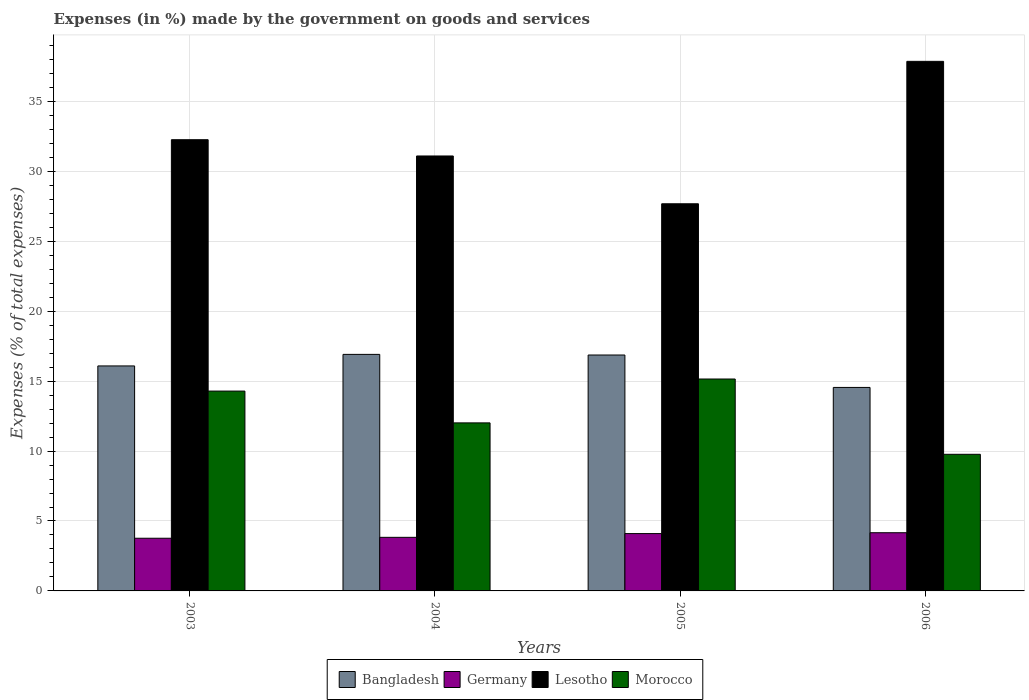How many bars are there on the 3rd tick from the right?
Your answer should be compact. 4. What is the percentage of expenses made by the government on goods and services in Bangladesh in 2003?
Your answer should be compact. 16.09. Across all years, what is the maximum percentage of expenses made by the government on goods and services in Lesotho?
Your answer should be very brief. 37.86. Across all years, what is the minimum percentage of expenses made by the government on goods and services in Morocco?
Provide a succinct answer. 9.77. What is the total percentage of expenses made by the government on goods and services in Germany in the graph?
Offer a very short reply. 15.86. What is the difference between the percentage of expenses made by the government on goods and services in Morocco in 2004 and that in 2005?
Ensure brevity in your answer.  -3.14. What is the difference between the percentage of expenses made by the government on goods and services in Morocco in 2003 and the percentage of expenses made by the government on goods and services in Lesotho in 2006?
Offer a terse response. -23.58. What is the average percentage of expenses made by the government on goods and services in Germany per year?
Make the answer very short. 3.96. In the year 2005, what is the difference between the percentage of expenses made by the government on goods and services in Morocco and percentage of expenses made by the government on goods and services in Lesotho?
Your response must be concise. -12.53. What is the ratio of the percentage of expenses made by the government on goods and services in Bangladesh in 2003 to that in 2005?
Provide a short and direct response. 0.95. Is the difference between the percentage of expenses made by the government on goods and services in Morocco in 2003 and 2006 greater than the difference between the percentage of expenses made by the government on goods and services in Lesotho in 2003 and 2006?
Provide a short and direct response. Yes. What is the difference between the highest and the second highest percentage of expenses made by the government on goods and services in Morocco?
Your answer should be very brief. 0.86. What is the difference between the highest and the lowest percentage of expenses made by the government on goods and services in Bangladesh?
Provide a short and direct response. 2.36. In how many years, is the percentage of expenses made by the government on goods and services in Lesotho greater than the average percentage of expenses made by the government on goods and services in Lesotho taken over all years?
Offer a terse response. 2. Is it the case that in every year, the sum of the percentage of expenses made by the government on goods and services in Morocco and percentage of expenses made by the government on goods and services in Lesotho is greater than the sum of percentage of expenses made by the government on goods and services in Germany and percentage of expenses made by the government on goods and services in Bangladesh?
Your answer should be very brief. No. What does the 4th bar from the left in 2004 represents?
Give a very brief answer. Morocco. What does the 1st bar from the right in 2004 represents?
Provide a succinct answer. Morocco. Is it the case that in every year, the sum of the percentage of expenses made by the government on goods and services in Bangladesh and percentage of expenses made by the government on goods and services in Morocco is greater than the percentage of expenses made by the government on goods and services in Lesotho?
Offer a very short reply. No. Are all the bars in the graph horizontal?
Provide a succinct answer. No. What is the difference between two consecutive major ticks on the Y-axis?
Provide a short and direct response. 5. Does the graph contain any zero values?
Make the answer very short. No. Does the graph contain grids?
Provide a succinct answer. Yes. Where does the legend appear in the graph?
Offer a very short reply. Bottom center. How many legend labels are there?
Provide a succinct answer. 4. What is the title of the graph?
Offer a very short reply. Expenses (in %) made by the government on goods and services. What is the label or title of the Y-axis?
Offer a terse response. Expenses (% of total expenses). What is the Expenses (% of total expenses) in Bangladesh in 2003?
Make the answer very short. 16.09. What is the Expenses (% of total expenses) in Germany in 2003?
Offer a terse response. 3.77. What is the Expenses (% of total expenses) of Lesotho in 2003?
Your answer should be compact. 32.26. What is the Expenses (% of total expenses) of Morocco in 2003?
Keep it short and to the point. 14.29. What is the Expenses (% of total expenses) of Bangladesh in 2004?
Give a very brief answer. 16.91. What is the Expenses (% of total expenses) of Germany in 2004?
Provide a short and direct response. 3.83. What is the Expenses (% of total expenses) of Lesotho in 2004?
Make the answer very short. 31.1. What is the Expenses (% of total expenses) of Morocco in 2004?
Provide a succinct answer. 12.01. What is the Expenses (% of total expenses) of Bangladesh in 2005?
Your response must be concise. 16.87. What is the Expenses (% of total expenses) of Germany in 2005?
Your answer should be compact. 4.1. What is the Expenses (% of total expenses) of Lesotho in 2005?
Your answer should be compact. 27.68. What is the Expenses (% of total expenses) of Morocco in 2005?
Provide a short and direct response. 15.15. What is the Expenses (% of total expenses) in Bangladesh in 2006?
Offer a very short reply. 14.55. What is the Expenses (% of total expenses) of Germany in 2006?
Give a very brief answer. 4.16. What is the Expenses (% of total expenses) in Lesotho in 2006?
Offer a very short reply. 37.86. What is the Expenses (% of total expenses) of Morocco in 2006?
Offer a terse response. 9.77. Across all years, what is the maximum Expenses (% of total expenses) in Bangladesh?
Offer a very short reply. 16.91. Across all years, what is the maximum Expenses (% of total expenses) of Germany?
Make the answer very short. 4.16. Across all years, what is the maximum Expenses (% of total expenses) of Lesotho?
Offer a very short reply. 37.86. Across all years, what is the maximum Expenses (% of total expenses) of Morocco?
Your response must be concise. 15.15. Across all years, what is the minimum Expenses (% of total expenses) of Bangladesh?
Provide a short and direct response. 14.55. Across all years, what is the minimum Expenses (% of total expenses) in Germany?
Offer a very short reply. 3.77. Across all years, what is the minimum Expenses (% of total expenses) in Lesotho?
Make the answer very short. 27.68. Across all years, what is the minimum Expenses (% of total expenses) in Morocco?
Ensure brevity in your answer.  9.77. What is the total Expenses (% of total expenses) of Bangladesh in the graph?
Provide a short and direct response. 64.42. What is the total Expenses (% of total expenses) of Germany in the graph?
Your answer should be compact. 15.86. What is the total Expenses (% of total expenses) in Lesotho in the graph?
Ensure brevity in your answer.  128.9. What is the total Expenses (% of total expenses) of Morocco in the graph?
Your answer should be very brief. 51.22. What is the difference between the Expenses (% of total expenses) of Bangladesh in 2003 and that in 2004?
Provide a succinct answer. -0.83. What is the difference between the Expenses (% of total expenses) in Germany in 2003 and that in 2004?
Provide a succinct answer. -0.06. What is the difference between the Expenses (% of total expenses) of Lesotho in 2003 and that in 2004?
Offer a very short reply. 1.16. What is the difference between the Expenses (% of total expenses) in Morocco in 2003 and that in 2004?
Give a very brief answer. 2.27. What is the difference between the Expenses (% of total expenses) in Bangladesh in 2003 and that in 2005?
Ensure brevity in your answer.  -0.78. What is the difference between the Expenses (% of total expenses) in Germany in 2003 and that in 2005?
Make the answer very short. -0.33. What is the difference between the Expenses (% of total expenses) of Lesotho in 2003 and that in 2005?
Ensure brevity in your answer.  4.58. What is the difference between the Expenses (% of total expenses) of Morocco in 2003 and that in 2005?
Your answer should be compact. -0.86. What is the difference between the Expenses (% of total expenses) of Bangladesh in 2003 and that in 2006?
Offer a very short reply. 1.54. What is the difference between the Expenses (% of total expenses) of Germany in 2003 and that in 2006?
Your answer should be compact. -0.39. What is the difference between the Expenses (% of total expenses) in Lesotho in 2003 and that in 2006?
Offer a terse response. -5.6. What is the difference between the Expenses (% of total expenses) of Morocco in 2003 and that in 2006?
Your answer should be very brief. 4.52. What is the difference between the Expenses (% of total expenses) of Bangladesh in 2004 and that in 2005?
Make the answer very short. 0.04. What is the difference between the Expenses (% of total expenses) of Germany in 2004 and that in 2005?
Give a very brief answer. -0.27. What is the difference between the Expenses (% of total expenses) of Lesotho in 2004 and that in 2005?
Ensure brevity in your answer.  3.42. What is the difference between the Expenses (% of total expenses) in Morocco in 2004 and that in 2005?
Offer a very short reply. -3.14. What is the difference between the Expenses (% of total expenses) of Bangladesh in 2004 and that in 2006?
Ensure brevity in your answer.  2.36. What is the difference between the Expenses (% of total expenses) in Germany in 2004 and that in 2006?
Keep it short and to the point. -0.33. What is the difference between the Expenses (% of total expenses) in Lesotho in 2004 and that in 2006?
Your response must be concise. -6.77. What is the difference between the Expenses (% of total expenses) of Morocco in 2004 and that in 2006?
Ensure brevity in your answer.  2.25. What is the difference between the Expenses (% of total expenses) in Bangladesh in 2005 and that in 2006?
Offer a very short reply. 2.32. What is the difference between the Expenses (% of total expenses) of Germany in 2005 and that in 2006?
Make the answer very short. -0.06. What is the difference between the Expenses (% of total expenses) in Lesotho in 2005 and that in 2006?
Make the answer very short. -10.18. What is the difference between the Expenses (% of total expenses) of Morocco in 2005 and that in 2006?
Provide a short and direct response. 5.38. What is the difference between the Expenses (% of total expenses) in Bangladesh in 2003 and the Expenses (% of total expenses) in Germany in 2004?
Give a very brief answer. 12.26. What is the difference between the Expenses (% of total expenses) in Bangladesh in 2003 and the Expenses (% of total expenses) in Lesotho in 2004?
Ensure brevity in your answer.  -15.01. What is the difference between the Expenses (% of total expenses) in Bangladesh in 2003 and the Expenses (% of total expenses) in Morocco in 2004?
Your answer should be compact. 4.07. What is the difference between the Expenses (% of total expenses) in Germany in 2003 and the Expenses (% of total expenses) in Lesotho in 2004?
Make the answer very short. -27.33. What is the difference between the Expenses (% of total expenses) in Germany in 2003 and the Expenses (% of total expenses) in Morocco in 2004?
Keep it short and to the point. -8.25. What is the difference between the Expenses (% of total expenses) in Lesotho in 2003 and the Expenses (% of total expenses) in Morocco in 2004?
Your answer should be compact. 20.25. What is the difference between the Expenses (% of total expenses) in Bangladesh in 2003 and the Expenses (% of total expenses) in Germany in 2005?
Make the answer very short. 11.99. What is the difference between the Expenses (% of total expenses) of Bangladesh in 2003 and the Expenses (% of total expenses) of Lesotho in 2005?
Offer a terse response. -11.59. What is the difference between the Expenses (% of total expenses) in Bangladesh in 2003 and the Expenses (% of total expenses) in Morocco in 2005?
Offer a terse response. 0.94. What is the difference between the Expenses (% of total expenses) in Germany in 2003 and the Expenses (% of total expenses) in Lesotho in 2005?
Your response must be concise. -23.91. What is the difference between the Expenses (% of total expenses) of Germany in 2003 and the Expenses (% of total expenses) of Morocco in 2005?
Ensure brevity in your answer.  -11.38. What is the difference between the Expenses (% of total expenses) of Lesotho in 2003 and the Expenses (% of total expenses) of Morocco in 2005?
Your answer should be compact. 17.11. What is the difference between the Expenses (% of total expenses) of Bangladesh in 2003 and the Expenses (% of total expenses) of Germany in 2006?
Keep it short and to the point. 11.93. What is the difference between the Expenses (% of total expenses) in Bangladesh in 2003 and the Expenses (% of total expenses) in Lesotho in 2006?
Make the answer very short. -21.78. What is the difference between the Expenses (% of total expenses) of Bangladesh in 2003 and the Expenses (% of total expenses) of Morocco in 2006?
Offer a terse response. 6.32. What is the difference between the Expenses (% of total expenses) in Germany in 2003 and the Expenses (% of total expenses) in Lesotho in 2006?
Give a very brief answer. -34.1. What is the difference between the Expenses (% of total expenses) of Germany in 2003 and the Expenses (% of total expenses) of Morocco in 2006?
Your answer should be compact. -6. What is the difference between the Expenses (% of total expenses) of Lesotho in 2003 and the Expenses (% of total expenses) of Morocco in 2006?
Ensure brevity in your answer.  22.49. What is the difference between the Expenses (% of total expenses) of Bangladesh in 2004 and the Expenses (% of total expenses) of Germany in 2005?
Offer a terse response. 12.81. What is the difference between the Expenses (% of total expenses) in Bangladesh in 2004 and the Expenses (% of total expenses) in Lesotho in 2005?
Give a very brief answer. -10.77. What is the difference between the Expenses (% of total expenses) in Bangladesh in 2004 and the Expenses (% of total expenses) in Morocco in 2005?
Provide a succinct answer. 1.76. What is the difference between the Expenses (% of total expenses) in Germany in 2004 and the Expenses (% of total expenses) in Lesotho in 2005?
Your response must be concise. -23.85. What is the difference between the Expenses (% of total expenses) of Germany in 2004 and the Expenses (% of total expenses) of Morocco in 2005?
Ensure brevity in your answer.  -11.32. What is the difference between the Expenses (% of total expenses) in Lesotho in 2004 and the Expenses (% of total expenses) in Morocco in 2005?
Give a very brief answer. 15.95. What is the difference between the Expenses (% of total expenses) in Bangladesh in 2004 and the Expenses (% of total expenses) in Germany in 2006?
Offer a terse response. 12.75. What is the difference between the Expenses (% of total expenses) of Bangladesh in 2004 and the Expenses (% of total expenses) of Lesotho in 2006?
Offer a terse response. -20.95. What is the difference between the Expenses (% of total expenses) in Bangladesh in 2004 and the Expenses (% of total expenses) in Morocco in 2006?
Offer a terse response. 7.14. What is the difference between the Expenses (% of total expenses) of Germany in 2004 and the Expenses (% of total expenses) of Lesotho in 2006?
Provide a succinct answer. -34.03. What is the difference between the Expenses (% of total expenses) in Germany in 2004 and the Expenses (% of total expenses) in Morocco in 2006?
Offer a terse response. -5.94. What is the difference between the Expenses (% of total expenses) of Lesotho in 2004 and the Expenses (% of total expenses) of Morocco in 2006?
Offer a terse response. 21.33. What is the difference between the Expenses (% of total expenses) in Bangladesh in 2005 and the Expenses (% of total expenses) in Germany in 2006?
Make the answer very short. 12.71. What is the difference between the Expenses (% of total expenses) in Bangladesh in 2005 and the Expenses (% of total expenses) in Lesotho in 2006?
Make the answer very short. -21. What is the difference between the Expenses (% of total expenses) of Bangladesh in 2005 and the Expenses (% of total expenses) of Morocco in 2006?
Make the answer very short. 7.1. What is the difference between the Expenses (% of total expenses) of Germany in 2005 and the Expenses (% of total expenses) of Lesotho in 2006?
Your answer should be very brief. -33.76. What is the difference between the Expenses (% of total expenses) in Germany in 2005 and the Expenses (% of total expenses) in Morocco in 2006?
Provide a short and direct response. -5.67. What is the difference between the Expenses (% of total expenses) of Lesotho in 2005 and the Expenses (% of total expenses) of Morocco in 2006?
Provide a succinct answer. 17.91. What is the average Expenses (% of total expenses) of Bangladesh per year?
Ensure brevity in your answer.  16.1. What is the average Expenses (% of total expenses) in Germany per year?
Your answer should be very brief. 3.96. What is the average Expenses (% of total expenses) in Lesotho per year?
Your answer should be compact. 32.23. What is the average Expenses (% of total expenses) of Morocco per year?
Your answer should be compact. 12.81. In the year 2003, what is the difference between the Expenses (% of total expenses) of Bangladesh and Expenses (% of total expenses) of Germany?
Give a very brief answer. 12.32. In the year 2003, what is the difference between the Expenses (% of total expenses) of Bangladesh and Expenses (% of total expenses) of Lesotho?
Your response must be concise. -16.17. In the year 2003, what is the difference between the Expenses (% of total expenses) in Bangladesh and Expenses (% of total expenses) in Morocco?
Your answer should be compact. 1.8. In the year 2003, what is the difference between the Expenses (% of total expenses) of Germany and Expenses (% of total expenses) of Lesotho?
Your response must be concise. -28.49. In the year 2003, what is the difference between the Expenses (% of total expenses) of Germany and Expenses (% of total expenses) of Morocco?
Provide a succinct answer. -10.52. In the year 2003, what is the difference between the Expenses (% of total expenses) of Lesotho and Expenses (% of total expenses) of Morocco?
Keep it short and to the point. 17.97. In the year 2004, what is the difference between the Expenses (% of total expenses) of Bangladesh and Expenses (% of total expenses) of Germany?
Your answer should be compact. 13.08. In the year 2004, what is the difference between the Expenses (% of total expenses) in Bangladesh and Expenses (% of total expenses) in Lesotho?
Your answer should be compact. -14.19. In the year 2004, what is the difference between the Expenses (% of total expenses) in Bangladesh and Expenses (% of total expenses) in Morocco?
Your response must be concise. 4.9. In the year 2004, what is the difference between the Expenses (% of total expenses) in Germany and Expenses (% of total expenses) in Lesotho?
Offer a very short reply. -27.27. In the year 2004, what is the difference between the Expenses (% of total expenses) in Germany and Expenses (% of total expenses) in Morocco?
Keep it short and to the point. -8.18. In the year 2004, what is the difference between the Expenses (% of total expenses) of Lesotho and Expenses (% of total expenses) of Morocco?
Offer a very short reply. 19.08. In the year 2005, what is the difference between the Expenses (% of total expenses) in Bangladesh and Expenses (% of total expenses) in Germany?
Offer a terse response. 12.77. In the year 2005, what is the difference between the Expenses (% of total expenses) in Bangladesh and Expenses (% of total expenses) in Lesotho?
Offer a terse response. -10.81. In the year 2005, what is the difference between the Expenses (% of total expenses) in Bangladesh and Expenses (% of total expenses) in Morocco?
Keep it short and to the point. 1.72. In the year 2005, what is the difference between the Expenses (% of total expenses) in Germany and Expenses (% of total expenses) in Lesotho?
Make the answer very short. -23.58. In the year 2005, what is the difference between the Expenses (% of total expenses) in Germany and Expenses (% of total expenses) in Morocco?
Offer a very short reply. -11.05. In the year 2005, what is the difference between the Expenses (% of total expenses) in Lesotho and Expenses (% of total expenses) in Morocco?
Your response must be concise. 12.53. In the year 2006, what is the difference between the Expenses (% of total expenses) in Bangladesh and Expenses (% of total expenses) in Germany?
Your answer should be very brief. 10.39. In the year 2006, what is the difference between the Expenses (% of total expenses) of Bangladesh and Expenses (% of total expenses) of Lesotho?
Provide a short and direct response. -23.31. In the year 2006, what is the difference between the Expenses (% of total expenses) of Bangladesh and Expenses (% of total expenses) of Morocco?
Offer a terse response. 4.78. In the year 2006, what is the difference between the Expenses (% of total expenses) of Germany and Expenses (% of total expenses) of Lesotho?
Your response must be concise. -33.7. In the year 2006, what is the difference between the Expenses (% of total expenses) in Germany and Expenses (% of total expenses) in Morocco?
Give a very brief answer. -5.61. In the year 2006, what is the difference between the Expenses (% of total expenses) in Lesotho and Expenses (% of total expenses) in Morocco?
Provide a short and direct response. 28.09. What is the ratio of the Expenses (% of total expenses) of Bangladesh in 2003 to that in 2004?
Offer a terse response. 0.95. What is the ratio of the Expenses (% of total expenses) in Germany in 2003 to that in 2004?
Offer a terse response. 0.98. What is the ratio of the Expenses (% of total expenses) in Lesotho in 2003 to that in 2004?
Offer a very short reply. 1.04. What is the ratio of the Expenses (% of total expenses) in Morocco in 2003 to that in 2004?
Provide a short and direct response. 1.19. What is the ratio of the Expenses (% of total expenses) of Bangladesh in 2003 to that in 2005?
Make the answer very short. 0.95. What is the ratio of the Expenses (% of total expenses) in Germany in 2003 to that in 2005?
Your answer should be compact. 0.92. What is the ratio of the Expenses (% of total expenses) in Lesotho in 2003 to that in 2005?
Make the answer very short. 1.17. What is the ratio of the Expenses (% of total expenses) of Morocco in 2003 to that in 2005?
Offer a terse response. 0.94. What is the ratio of the Expenses (% of total expenses) of Bangladesh in 2003 to that in 2006?
Keep it short and to the point. 1.11. What is the ratio of the Expenses (% of total expenses) of Germany in 2003 to that in 2006?
Your response must be concise. 0.91. What is the ratio of the Expenses (% of total expenses) in Lesotho in 2003 to that in 2006?
Provide a short and direct response. 0.85. What is the ratio of the Expenses (% of total expenses) in Morocco in 2003 to that in 2006?
Provide a succinct answer. 1.46. What is the ratio of the Expenses (% of total expenses) of Bangladesh in 2004 to that in 2005?
Offer a terse response. 1. What is the ratio of the Expenses (% of total expenses) of Germany in 2004 to that in 2005?
Offer a very short reply. 0.93. What is the ratio of the Expenses (% of total expenses) of Lesotho in 2004 to that in 2005?
Your response must be concise. 1.12. What is the ratio of the Expenses (% of total expenses) in Morocco in 2004 to that in 2005?
Provide a short and direct response. 0.79. What is the ratio of the Expenses (% of total expenses) in Bangladesh in 2004 to that in 2006?
Give a very brief answer. 1.16. What is the ratio of the Expenses (% of total expenses) of Germany in 2004 to that in 2006?
Provide a succinct answer. 0.92. What is the ratio of the Expenses (% of total expenses) in Lesotho in 2004 to that in 2006?
Your answer should be very brief. 0.82. What is the ratio of the Expenses (% of total expenses) of Morocco in 2004 to that in 2006?
Keep it short and to the point. 1.23. What is the ratio of the Expenses (% of total expenses) in Bangladesh in 2005 to that in 2006?
Your answer should be compact. 1.16. What is the ratio of the Expenses (% of total expenses) in Germany in 2005 to that in 2006?
Make the answer very short. 0.99. What is the ratio of the Expenses (% of total expenses) of Lesotho in 2005 to that in 2006?
Provide a short and direct response. 0.73. What is the ratio of the Expenses (% of total expenses) in Morocco in 2005 to that in 2006?
Make the answer very short. 1.55. What is the difference between the highest and the second highest Expenses (% of total expenses) of Bangladesh?
Make the answer very short. 0.04. What is the difference between the highest and the second highest Expenses (% of total expenses) in Germany?
Make the answer very short. 0.06. What is the difference between the highest and the second highest Expenses (% of total expenses) in Lesotho?
Offer a terse response. 5.6. What is the difference between the highest and the second highest Expenses (% of total expenses) in Morocco?
Keep it short and to the point. 0.86. What is the difference between the highest and the lowest Expenses (% of total expenses) of Bangladesh?
Your answer should be compact. 2.36. What is the difference between the highest and the lowest Expenses (% of total expenses) of Germany?
Give a very brief answer. 0.39. What is the difference between the highest and the lowest Expenses (% of total expenses) of Lesotho?
Make the answer very short. 10.18. What is the difference between the highest and the lowest Expenses (% of total expenses) of Morocco?
Offer a terse response. 5.38. 